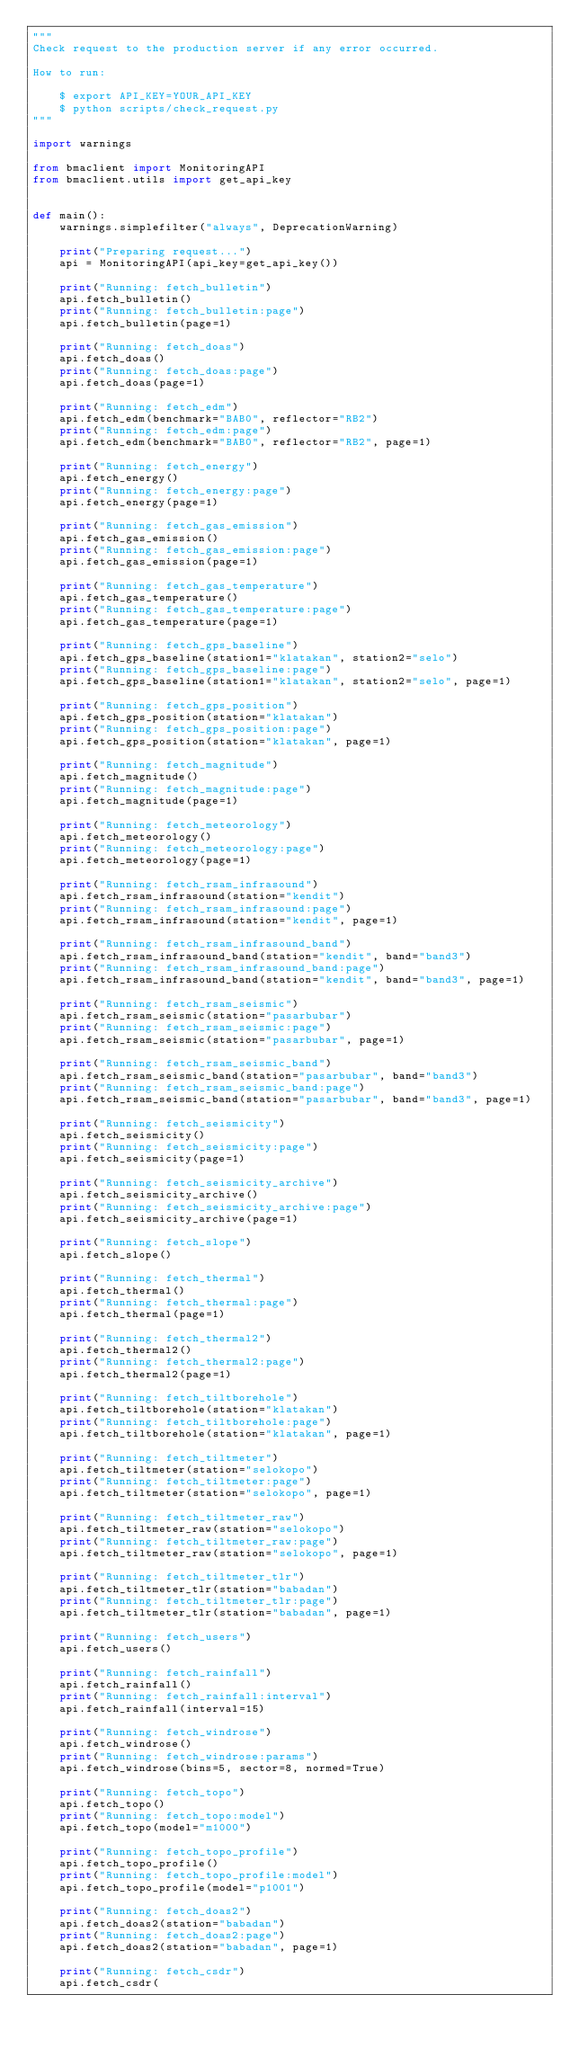<code> <loc_0><loc_0><loc_500><loc_500><_Python_>"""
Check request to the production server if any error occurred.

How to run:

    $ export API_KEY=YOUR_API_KEY
    $ python scripts/check_request.py
"""

import warnings

from bmaclient import MonitoringAPI
from bmaclient.utils import get_api_key


def main():
    warnings.simplefilter("always", DeprecationWarning)

    print("Preparing request...")
    api = MonitoringAPI(api_key=get_api_key())

    print("Running: fetch_bulletin")
    api.fetch_bulletin()
    print("Running: fetch_bulletin:page")
    api.fetch_bulletin(page=1)

    print("Running: fetch_doas")
    api.fetch_doas()
    print("Running: fetch_doas:page")
    api.fetch_doas(page=1)

    print("Running: fetch_edm")
    api.fetch_edm(benchmark="BAB0", reflector="RB2")
    print("Running: fetch_edm:page")
    api.fetch_edm(benchmark="BAB0", reflector="RB2", page=1)

    print("Running: fetch_energy")
    api.fetch_energy()
    print("Running: fetch_energy:page")
    api.fetch_energy(page=1)

    print("Running: fetch_gas_emission")
    api.fetch_gas_emission()
    print("Running: fetch_gas_emission:page")
    api.fetch_gas_emission(page=1)

    print("Running: fetch_gas_temperature")
    api.fetch_gas_temperature()
    print("Running: fetch_gas_temperature:page")
    api.fetch_gas_temperature(page=1)

    print("Running: fetch_gps_baseline")
    api.fetch_gps_baseline(station1="klatakan", station2="selo")
    print("Running: fetch_gps_baseline:page")
    api.fetch_gps_baseline(station1="klatakan", station2="selo", page=1)

    print("Running: fetch_gps_position")
    api.fetch_gps_position(station="klatakan")
    print("Running: fetch_gps_position:page")
    api.fetch_gps_position(station="klatakan", page=1)

    print("Running: fetch_magnitude")
    api.fetch_magnitude()
    print("Running: fetch_magnitude:page")
    api.fetch_magnitude(page=1)

    print("Running: fetch_meteorology")
    api.fetch_meteorology()
    print("Running: fetch_meteorology:page")
    api.fetch_meteorology(page=1)

    print("Running: fetch_rsam_infrasound")
    api.fetch_rsam_infrasound(station="kendit")
    print("Running: fetch_rsam_infrasound:page")
    api.fetch_rsam_infrasound(station="kendit", page=1)

    print("Running: fetch_rsam_infrasound_band")
    api.fetch_rsam_infrasound_band(station="kendit", band="band3")
    print("Running: fetch_rsam_infrasound_band:page")
    api.fetch_rsam_infrasound_band(station="kendit", band="band3", page=1)

    print("Running: fetch_rsam_seismic")
    api.fetch_rsam_seismic(station="pasarbubar")
    print("Running: fetch_rsam_seismic:page")
    api.fetch_rsam_seismic(station="pasarbubar", page=1)

    print("Running: fetch_rsam_seismic_band")
    api.fetch_rsam_seismic_band(station="pasarbubar", band="band3")
    print("Running: fetch_rsam_seismic_band:page")
    api.fetch_rsam_seismic_band(station="pasarbubar", band="band3", page=1)

    print("Running: fetch_seismicity")
    api.fetch_seismicity()
    print("Running: fetch_seismicity:page")
    api.fetch_seismicity(page=1)

    print("Running: fetch_seismicity_archive")
    api.fetch_seismicity_archive()
    print("Running: fetch_seismicity_archive:page")
    api.fetch_seismicity_archive(page=1)

    print("Running: fetch_slope")
    api.fetch_slope()

    print("Running: fetch_thermal")
    api.fetch_thermal()
    print("Running: fetch_thermal:page")
    api.fetch_thermal(page=1)

    print("Running: fetch_thermal2")
    api.fetch_thermal2()
    print("Running: fetch_thermal2:page")
    api.fetch_thermal2(page=1)

    print("Running: fetch_tiltborehole")
    api.fetch_tiltborehole(station="klatakan")
    print("Running: fetch_tiltborehole:page")
    api.fetch_tiltborehole(station="klatakan", page=1)

    print("Running: fetch_tiltmeter")
    api.fetch_tiltmeter(station="selokopo")
    print("Running: fetch_tiltmeter:page")
    api.fetch_tiltmeter(station="selokopo", page=1)

    print("Running: fetch_tiltmeter_raw")
    api.fetch_tiltmeter_raw(station="selokopo")
    print("Running: fetch_tiltmeter_raw:page")
    api.fetch_tiltmeter_raw(station="selokopo", page=1)

    print("Running: fetch_tiltmeter_tlr")
    api.fetch_tiltmeter_tlr(station="babadan")
    print("Running: fetch_tiltmeter_tlr:page")
    api.fetch_tiltmeter_tlr(station="babadan", page=1)

    print("Running: fetch_users")
    api.fetch_users()

    print("Running: fetch_rainfall")
    api.fetch_rainfall()
    print("Running: fetch_rainfall:interval")
    api.fetch_rainfall(interval=15)

    print("Running: fetch_windrose")
    api.fetch_windrose()
    print("Running: fetch_windrose:params")
    api.fetch_windrose(bins=5, sector=8, normed=True)

    print("Running: fetch_topo")
    api.fetch_topo()
    print("Running: fetch_topo:model")
    api.fetch_topo(model="m1000")

    print("Running: fetch_topo_profile")
    api.fetch_topo_profile()
    print("Running: fetch_topo_profile:model")
    api.fetch_topo_profile(model="p1001")

    print("Running: fetch_doas2")
    api.fetch_doas2(station="babadan")
    print("Running: fetch_doas2:page")
    api.fetch_doas2(station="babadan", page=1)

    print("Running: fetch_csdr")
    api.fetch_csdr(</code> 